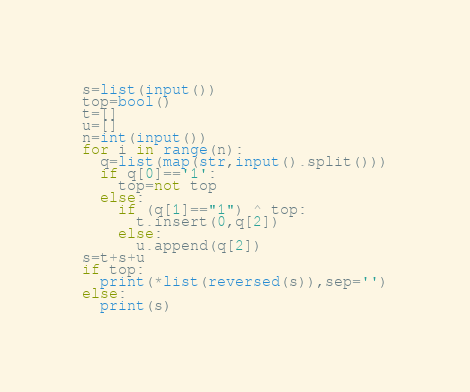Convert code to text. <code><loc_0><loc_0><loc_500><loc_500><_Python_>s=list(input())
top=bool()
t=[]
u=[]
n=int(input())
for i in range(n):
  q=list(map(str,input().split()))
  if q[0]=='1':
    top=not top
  else:
    if (q[1]=="1") ^ top:
      t.insert(0,q[2])
    else:
      u.append(q[2])
s=t+s+u
if top:
  print(*list(reversed(s)),sep='')
else:
  print(s)
</code> 